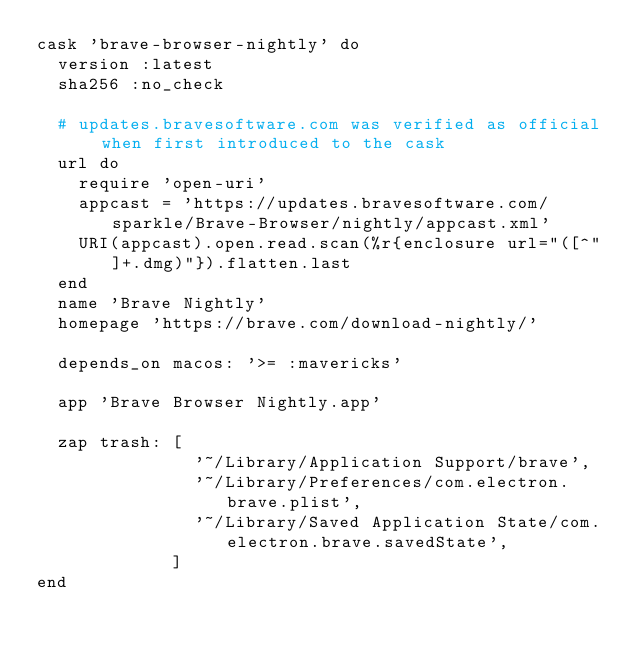<code> <loc_0><loc_0><loc_500><loc_500><_Ruby_>cask 'brave-browser-nightly' do
  version :latest
  sha256 :no_check

  # updates.bravesoftware.com was verified as official when first introduced to the cask
  url do
    require 'open-uri'
    appcast = 'https://updates.bravesoftware.com/sparkle/Brave-Browser/nightly/appcast.xml'
    URI(appcast).open.read.scan(%r{enclosure url="([^"]+.dmg)"}).flatten.last
  end
  name 'Brave Nightly'
  homepage 'https://brave.com/download-nightly/'

  depends_on macos: '>= :mavericks'

  app 'Brave Browser Nightly.app'

  zap trash: [
               '~/Library/Application Support/brave',
               '~/Library/Preferences/com.electron.brave.plist',
               '~/Library/Saved Application State/com.electron.brave.savedState',
             ]
end
</code> 